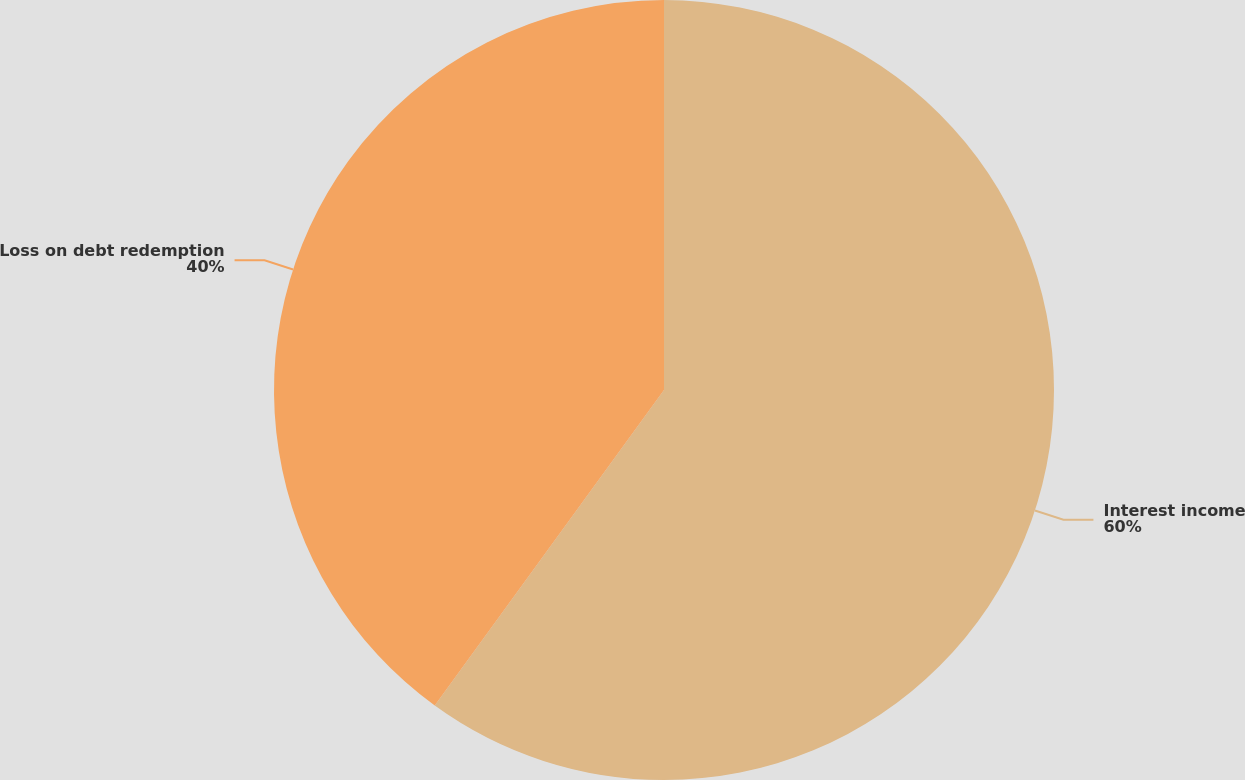<chart> <loc_0><loc_0><loc_500><loc_500><pie_chart><fcel>Interest income<fcel>Loss on debt redemption<nl><fcel>60.0%<fcel>40.0%<nl></chart> 